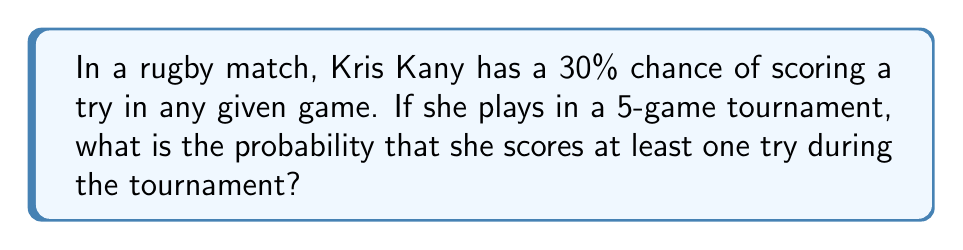Could you help me with this problem? Let's approach this step-by-step:

1) First, let's consider the probability of Kris not scoring in a single game:
   $P(\text{not scoring}) = 1 - P(\text{scoring}) = 1 - 0.30 = 0.70$

2) For Kris to not score at all during the tournament, she would need to not score in all 5 games. The probability of this is:
   $P(\text{no tries in 5 games}) = 0.70^5 = 0.16807$

3) Therefore, the probability of Kris scoring at least one try is the opposite of scoring no tries:
   $P(\text{at least one try}) = 1 - P(\text{no tries in 5 games})$
   $= 1 - 0.16807 = 0.83193$

4) We can also calculate this using the binomial probability formula:
   $P(X \geq 1) = 1 - P(X = 0)$
   $= 1 - \binom{5}{0}(0.30)^0(0.70)^5$
   $= 1 - 0.16807 = 0.83193$

Thus, there is approximately an 83.19% chance that Kris Kany scores at least one try during the 5-game tournament.
Answer: $0.83193$ or $83.19\%$ 